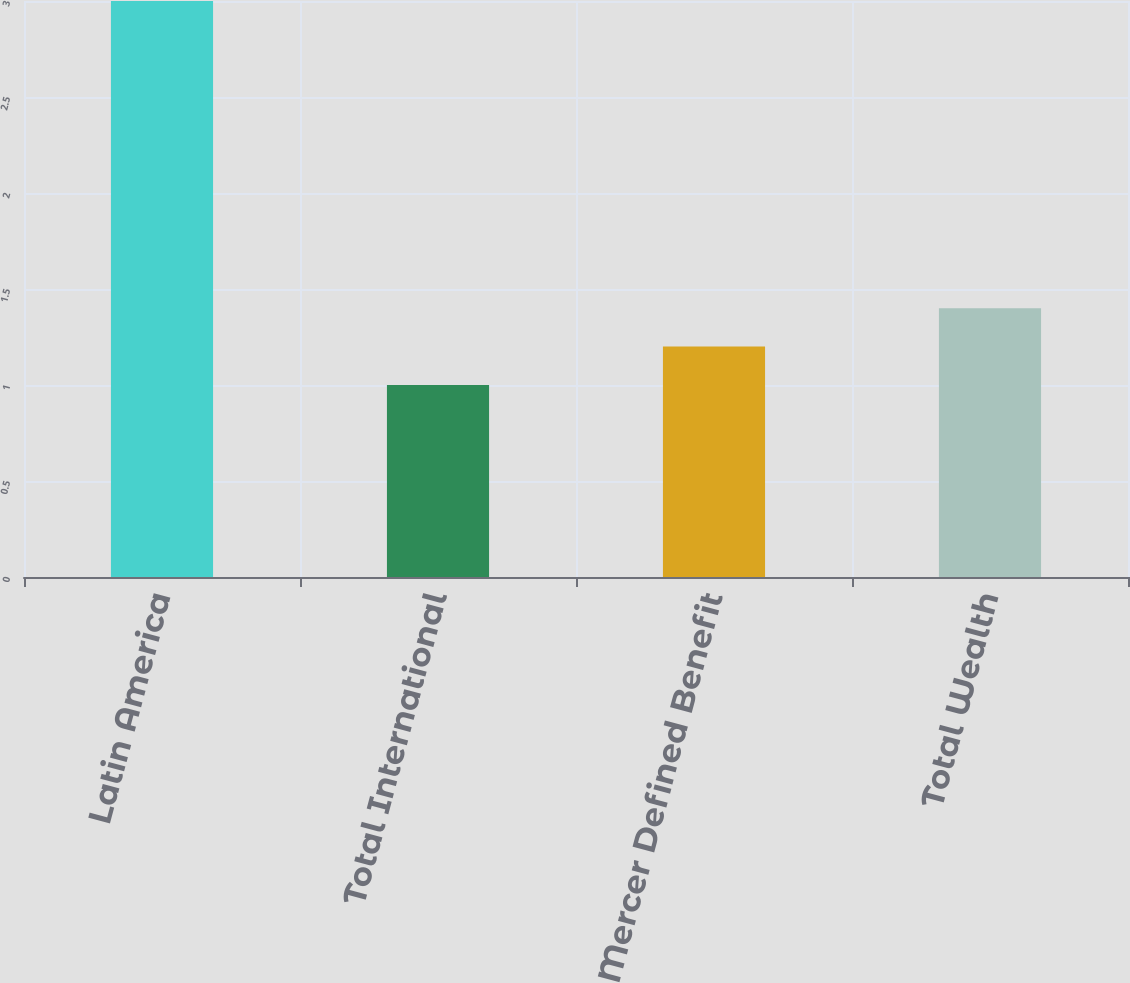<chart> <loc_0><loc_0><loc_500><loc_500><bar_chart><fcel>Latin America<fcel>Total International<fcel>Mercer Defined Benefit<fcel>Total Wealth<nl><fcel>3<fcel>1<fcel>1.2<fcel>1.4<nl></chart> 